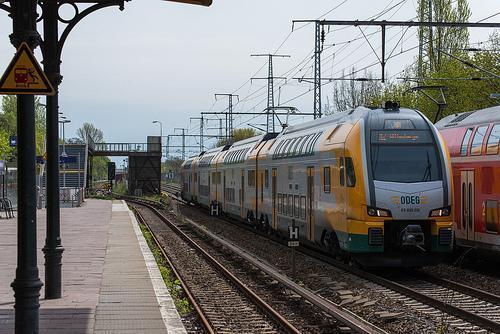How many trains are in the picture?
Give a very brief answer. 2. How many staircases are in the picture?
Give a very brief answer. 1. 